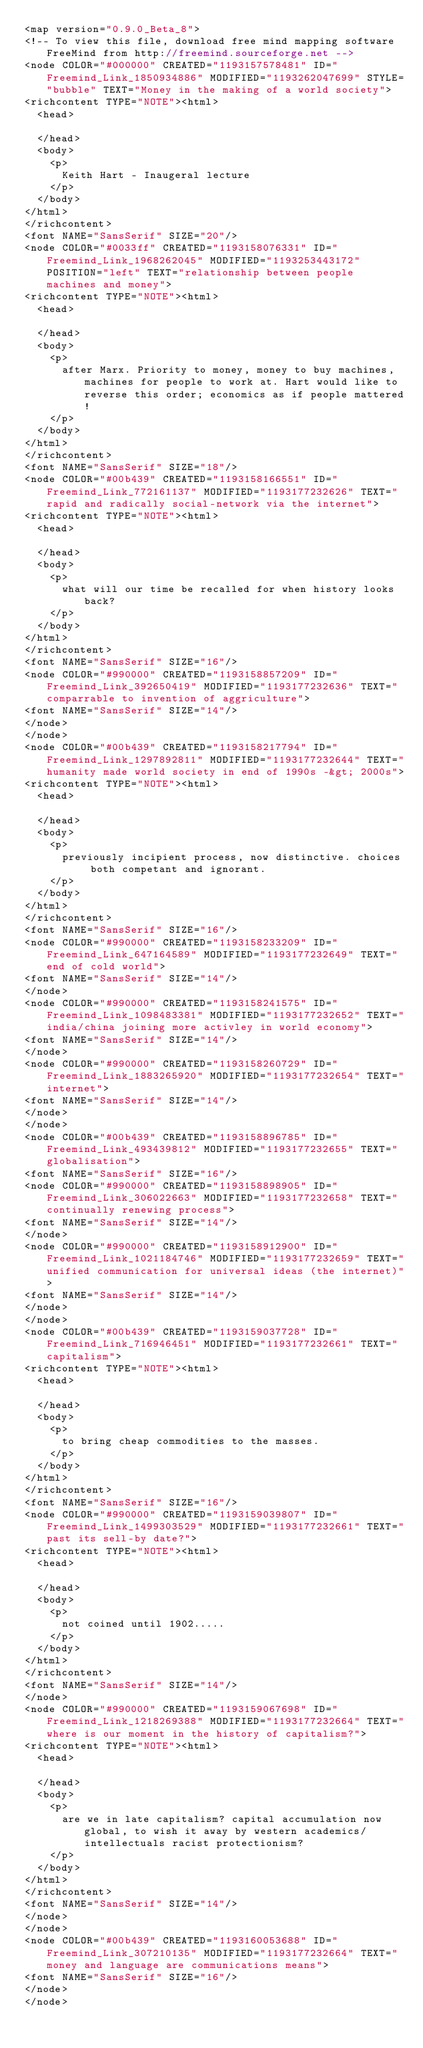Convert code to text. <code><loc_0><loc_0><loc_500><loc_500><_ObjectiveC_><map version="0.9.0_Beta_8">
<!-- To view this file, download free mind mapping software FreeMind from http://freemind.sourceforge.net -->
<node COLOR="#000000" CREATED="1193157578481" ID="Freemind_Link_1850934886" MODIFIED="1193262047699" STYLE="bubble" TEXT="Money in the making of a world society">
<richcontent TYPE="NOTE"><html>
  <head>
    
  </head>
  <body>
    <p>
      Keith Hart - Inaugeral lecture
    </p>
  </body>
</html>
</richcontent>
<font NAME="SansSerif" SIZE="20"/>
<node COLOR="#0033ff" CREATED="1193158076331" ID="Freemind_Link_1968262045" MODIFIED="1193253443172" POSITION="left" TEXT="relationship between people machines and money">
<richcontent TYPE="NOTE"><html>
  <head>
    
  </head>
  <body>
    <p>
      after Marx. Priority to money, money to buy machines, machines for people to work at. Hart would like to reverse this order; economics as if people mattered!
    </p>
  </body>
</html>
</richcontent>
<font NAME="SansSerif" SIZE="18"/>
<node COLOR="#00b439" CREATED="1193158166551" ID="Freemind_Link_772161137" MODIFIED="1193177232626" TEXT="rapid and radically social-network via the internet">
<richcontent TYPE="NOTE"><html>
  <head>
    
  </head>
  <body>
    <p>
      what will our time be recalled for when history looks back?
    </p>
  </body>
</html>
</richcontent>
<font NAME="SansSerif" SIZE="16"/>
<node COLOR="#990000" CREATED="1193158857209" ID="Freemind_Link_392650419" MODIFIED="1193177232636" TEXT="comparrable to invention of aggriculture">
<font NAME="SansSerif" SIZE="14"/>
</node>
</node>
<node COLOR="#00b439" CREATED="1193158217794" ID="Freemind_Link_1297892811" MODIFIED="1193177232644" TEXT="humanity made world society in end of 1990s -&gt; 2000s">
<richcontent TYPE="NOTE"><html>
  <head>
    
  </head>
  <body>
    <p>
      previously incipient process, now distinctive. choices both competant and ignorant.
    </p>
  </body>
</html>
</richcontent>
<font NAME="SansSerif" SIZE="16"/>
<node COLOR="#990000" CREATED="1193158233209" ID="Freemind_Link_647164589" MODIFIED="1193177232649" TEXT="end of cold world">
<font NAME="SansSerif" SIZE="14"/>
</node>
<node COLOR="#990000" CREATED="1193158241575" ID="Freemind_Link_1098483381" MODIFIED="1193177232652" TEXT="india/china joining more activley in world economy">
<font NAME="SansSerif" SIZE="14"/>
</node>
<node COLOR="#990000" CREATED="1193158260729" ID="Freemind_Link_1883265920" MODIFIED="1193177232654" TEXT="internet">
<font NAME="SansSerif" SIZE="14"/>
</node>
</node>
<node COLOR="#00b439" CREATED="1193158896785" ID="Freemind_Link_493439812" MODIFIED="1193177232655" TEXT="globalisation">
<font NAME="SansSerif" SIZE="16"/>
<node COLOR="#990000" CREATED="1193158898905" ID="Freemind_Link_306022663" MODIFIED="1193177232658" TEXT="continually renewing process">
<font NAME="SansSerif" SIZE="14"/>
</node>
<node COLOR="#990000" CREATED="1193158912900" ID="Freemind_Link_1021184746" MODIFIED="1193177232659" TEXT="unified communication for universal ideas (the internet)">
<font NAME="SansSerif" SIZE="14"/>
</node>
</node>
<node COLOR="#00b439" CREATED="1193159037728" ID="Freemind_Link_716946451" MODIFIED="1193177232661" TEXT="capitalism">
<richcontent TYPE="NOTE"><html>
  <head>
    
  </head>
  <body>
    <p>
      to bring cheap commodities to the masses.
    </p>
  </body>
</html>
</richcontent>
<font NAME="SansSerif" SIZE="16"/>
<node COLOR="#990000" CREATED="1193159039807" ID="Freemind_Link_1499303529" MODIFIED="1193177232661" TEXT="past its sell-by date?">
<richcontent TYPE="NOTE"><html>
  <head>
    
  </head>
  <body>
    <p>
      not coined until 1902.....
    </p>
  </body>
</html>
</richcontent>
<font NAME="SansSerif" SIZE="14"/>
</node>
<node COLOR="#990000" CREATED="1193159067698" ID="Freemind_Link_1218269388" MODIFIED="1193177232664" TEXT="where is our moment in the history of capitalism?">
<richcontent TYPE="NOTE"><html>
  <head>
    
  </head>
  <body>
    <p>
      are we in late capitalism? capital accumulation now global, to wish it away by western academics/intellectuals racist protectionism?
    </p>
  </body>
</html>
</richcontent>
<font NAME="SansSerif" SIZE="14"/>
</node>
</node>
<node COLOR="#00b439" CREATED="1193160053688" ID="Freemind_Link_307210135" MODIFIED="1193177232664" TEXT="money and language are communications means">
<font NAME="SansSerif" SIZE="16"/>
</node>
</node></code> 